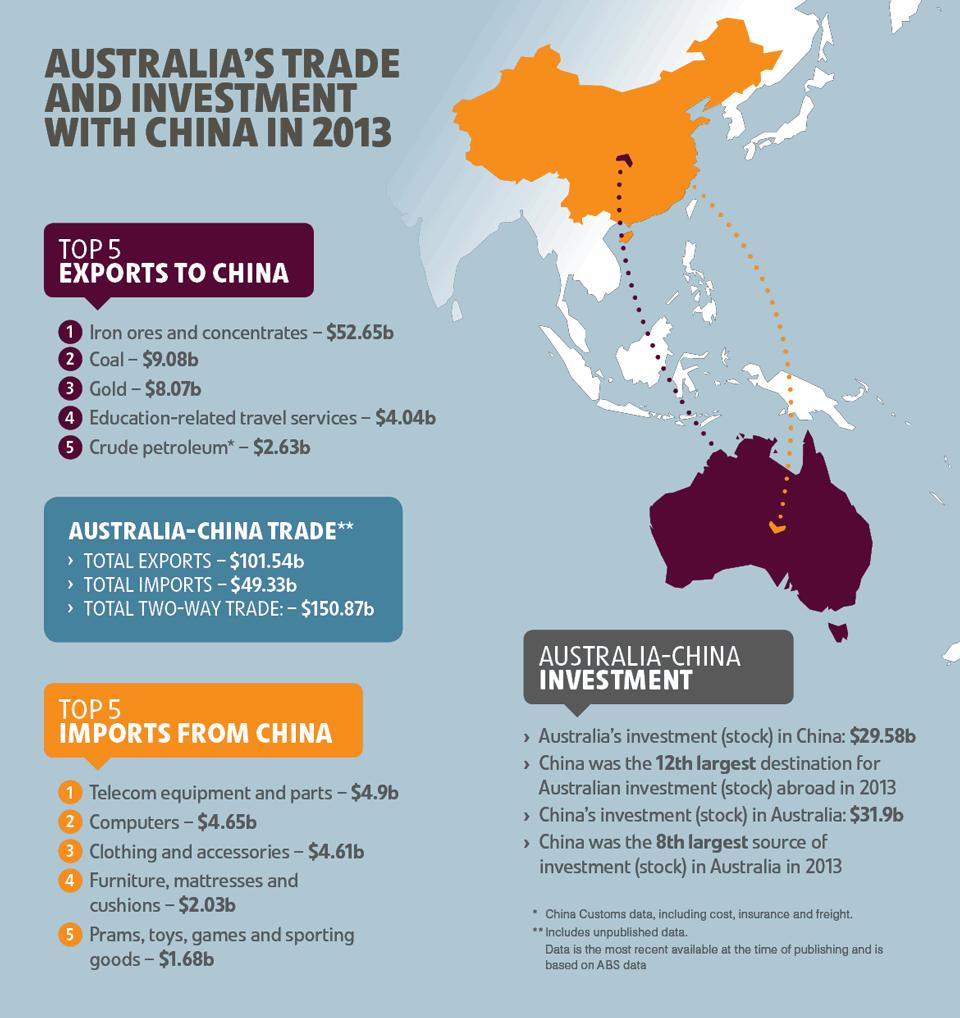Specify some key components in this picture. The color of the map of Australia is purple, and it is also stated that it is purple. The total of the 2nd and 3rd imports from China is 9.26. The total value of gold and coal exports was 17.15. The value of item 5 was less than item 3 in imports from China by 2.93... The value of exports is greater than the value of imports, with a difference of 52.21. 